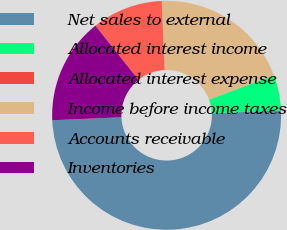Convert chart. <chart><loc_0><loc_0><loc_500><loc_500><pie_chart><fcel>Net sales to external<fcel>Allocated interest income<fcel>Allocated interest expense<fcel>Income before income taxes<fcel>Accounts receivable<fcel>Inventories<nl><fcel>49.99%<fcel>5.0%<fcel>0.0%<fcel>20.0%<fcel>10.0%<fcel>15.0%<nl></chart> 